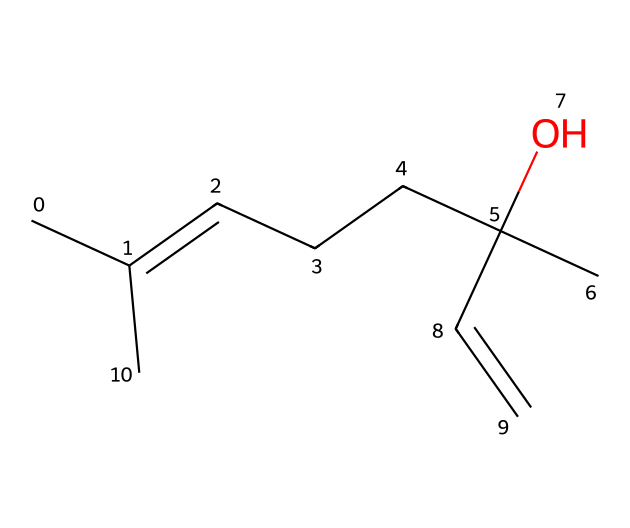What is the molecular formula of linalool? To determine the molecular formula, count the number of each type of atom present in the SMILES representation. There are 10 carbon (C) atoms, 18 hydrogen (H) atoms, and 1 oxygen (O) atom. Therefore, the molecular formula is C10H18O.
Answer: C10H18O How many double bonds are present in linalool? By analyzing the structure from the SMILES notation, identify where the double bonds exist. In this compound, there are 2 locations with double bonds, indicated by the '=' symbol.
Answer: 2 What functional group is present in linalool? The presence of the 'C(O)' part in the SMILES indicates the presence of a hydroxyl group (-OH), which is characteristic of alcohols. Thus, linalool contains a hydroxyl functional group.
Answer: hydroxyl What is the classification of linalool among terpenes? Linalool is a terpenoid, which is a subclass of terpenes that includes oxygen-containing compounds. Analyzing its structure shows that it has an alcohol functional group, confirming it as a terpene alcohol.
Answer: terpene alcohol How many chiral centers does linalool have? A chiral center is typically a carbon atom bonded to four different groups. By examining the structure of linalool, we can see that at least one carbon, specifically the one bonded to the hydroxyl group, has four different substituents, indicating it is a chiral center.
Answer: 1 What type of isomer is linalool classified as? Linalool exists in two forms, known as enantiomers, which are non-superimposable mirror images of each other. This classification is due to the presence of a chiral center in its structure.
Answer: enantiomer 